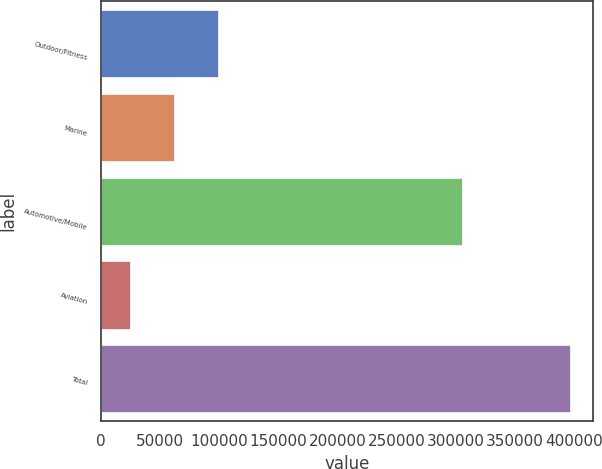Convert chart. <chart><loc_0><loc_0><loc_500><loc_500><bar_chart><fcel>Outdoor/Fitness<fcel>Marine<fcel>Automotive/Mobile<fcel>Aviation<fcel>Total<nl><fcel>98819.6<fcel>61609.8<fcel>305065<fcel>24400<fcel>396498<nl></chart> 